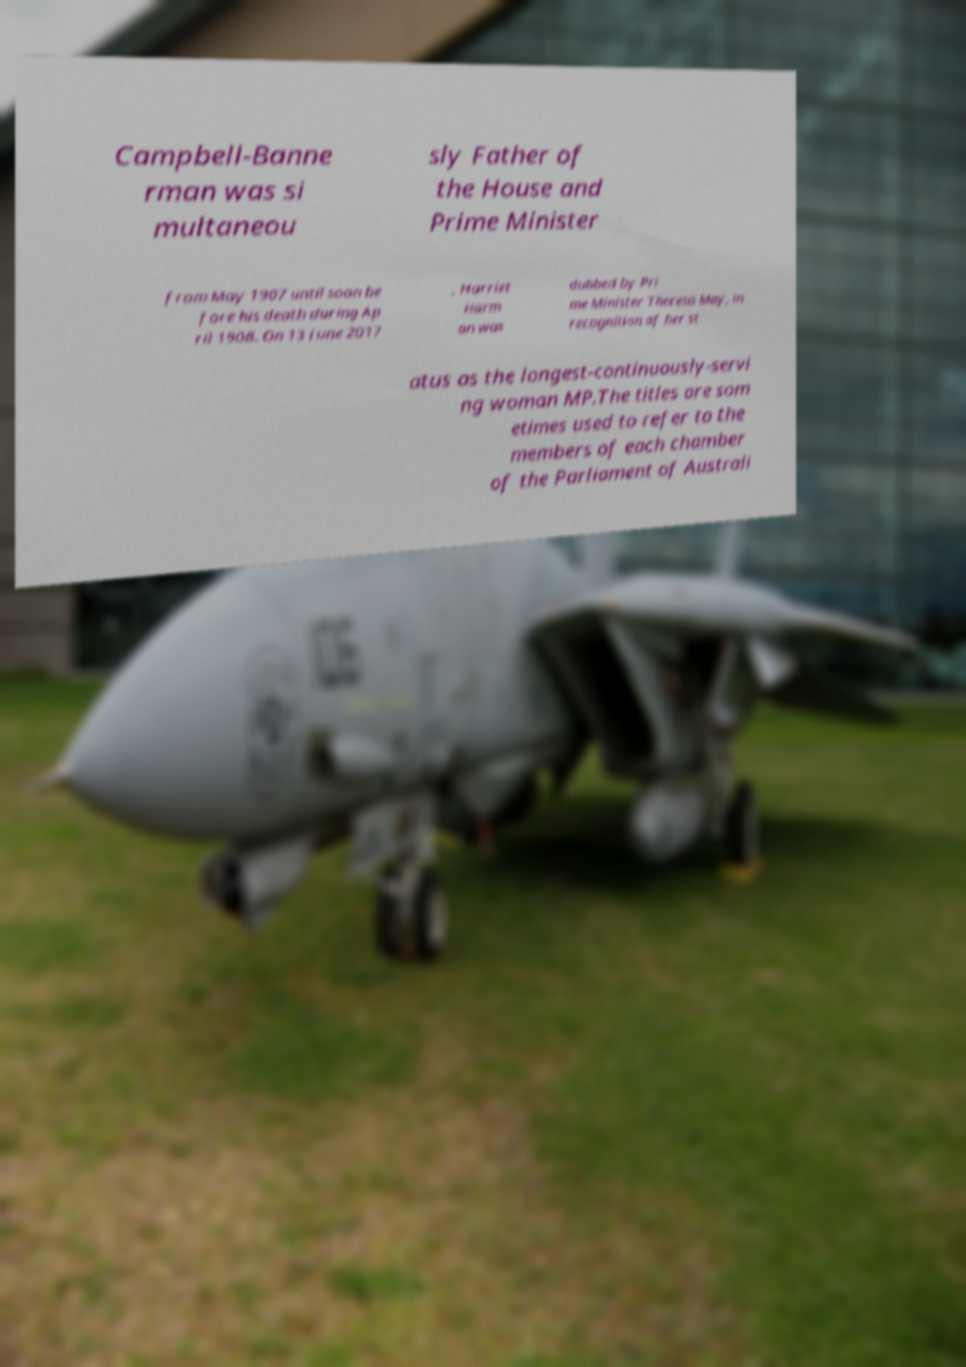Could you assist in decoding the text presented in this image and type it out clearly? Campbell-Banne rman was si multaneou sly Father of the House and Prime Minister from May 1907 until soon be fore his death during Ap ril 1908. On 13 June 2017 , Harriet Harm an was dubbed by Pri me Minister Theresa May, in recognition of her st atus as the longest-continuously-servi ng woman MP.The titles are som etimes used to refer to the members of each chamber of the Parliament of Australi 